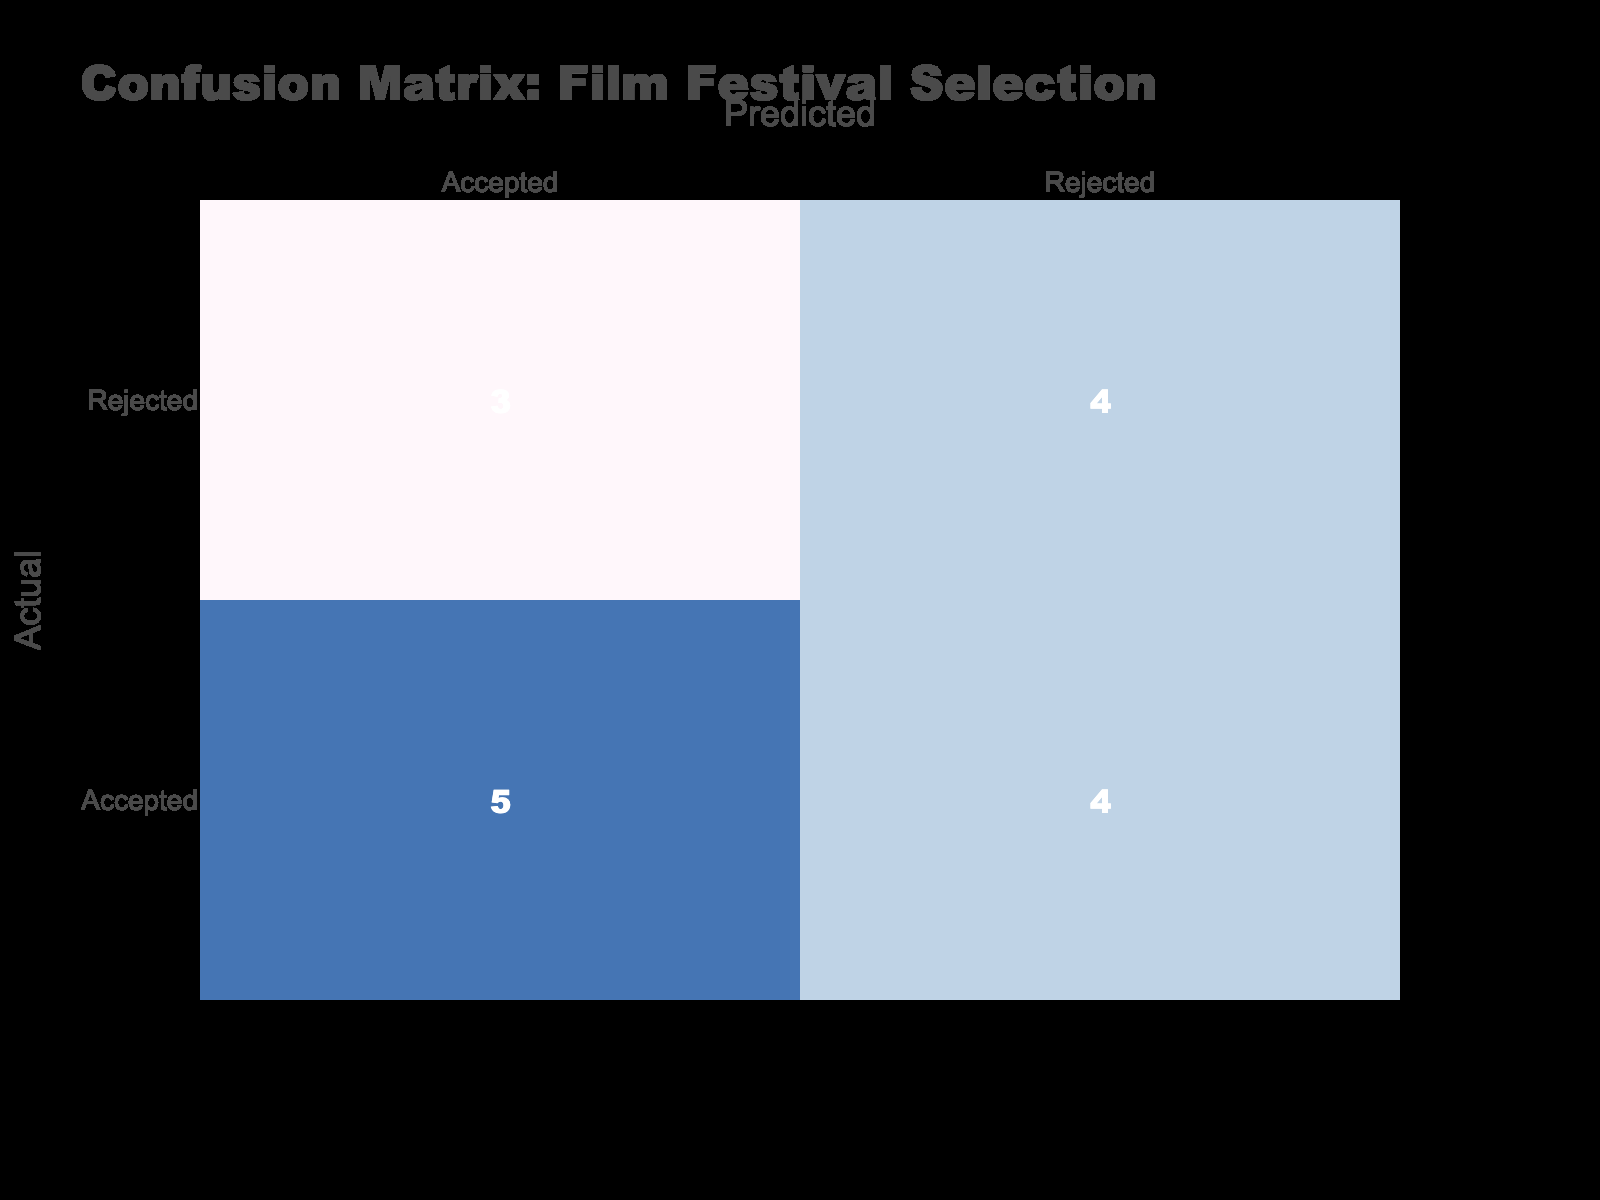What is the total number of predictions made for the "Accepted" category? In the "Accepted" category, the predictions made total up from the corresponding cell values in the confusion matrix. The accepted predictions are found in the cells where the actual value is "Accepted" and the predicted value is "Accepted", which has a count of 5, plus the cell where the actual value is "Rejected" and the predicted value is "Accepted", which has a count of 3. Therefore, the total is 5 + 3 = 8.
Answer: 8 What is the number of times the “Rejected” category was predicted wrongly? The "Rejected" category was predicted wrongly when the actual value is "Rejected" but the prediction was "Accepted." This occurs 3 times based on the data, as there are 3 instances where the actual outcome is rejected, but the model incorrectly predicted accepted.
Answer: 3 How many times did the model correctly predict "Rejected"? To find the number of correct predictions for "Rejected," we look at the cell for actual "Rejected" and predicted "Rejected." The value in this cell is 5, indicating that the model correctly predicted "Rejected" 5 times.
Answer: 5 Was the prediction accuracy higher for the "Accepted" or "Rejected" category? We assess the accuracy per category by comparing the number of correct predictions to the total instances. For "Accepted," there are 5 correct predictions out of 8 tests, resulting in an accuracy of 0.625 or 62.5%. For "Rejected," the accuracy is 5 correct out of 8 total tests, also resulting in an accuracy of 0.625 or 62.5%. Therefore, both categories have the same accuracy.
Answer: No What is the difference in the total counts of "Accepted" and "Rejected" predictions? To find this difference, we sum the counts of predictions for each category. "Accepted" has a total of 8, while "Rejected" has a total of 6 (5 correct + 1 incorrect). Thus, the difference is calculated as 8 - 6 = 2.
Answer: 2 How many total predictions were made for the film festival selection? The total predictions made can be obtained by adding the totals from both the "Accepted" and "Rejected" categories. For "Accepted," there are 8 predictions and for "Rejected," there are 6 predictions. Therefore, the total predictions equal 8 + 6 = 14.
Answer: 14 How many times did the model predict "Accepted" correctly? The model predicted "Accepted" correctly when both the actual and predicted values were "Accepted." This was recorded in the confusion matrix as 5 occurrences. So, the count of correct predictions for "Accepted" is 5.
Answer: 5 What percentage of total predictions were correct overall? To determine this percentage, we first find the total number of correct predictions. There are 5 correct "Accepted" predictions and 5 correct "Rejected" predictions, totaling 10 correct predictions. The total predictions made amount to 14. The percentage is then calculated as (10/14) * 100, which gives approximately 71.43%.
Answer: 71.43% 